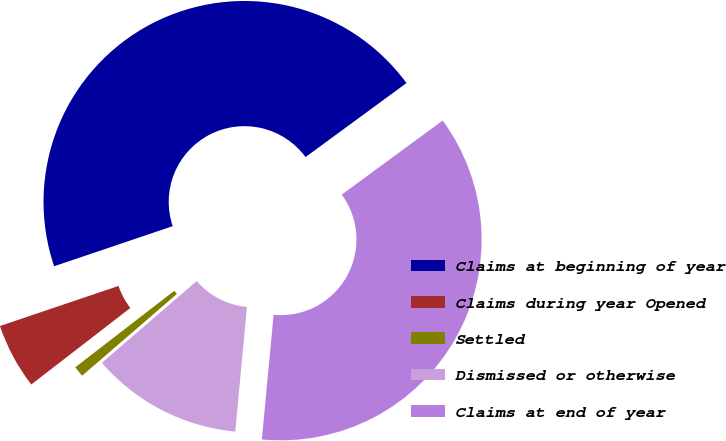Convert chart. <chart><loc_0><loc_0><loc_500><loc_500><pie_chart><fcel>Claims at beginning of year<fcel>Claims during year Opened<fcel>Settled<fcel>Dismissed or otherwise<fcel>Claims at end of year<nl><fcel>45.12%<fcel>5.28%<fcel>0.86%<fcel>12.18%<fcel>36.57%<nl></chart> 